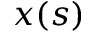Convert formula to latex. <formula><loc_0><loc_0><loc_500><loc_500>x ( s )</formula> 